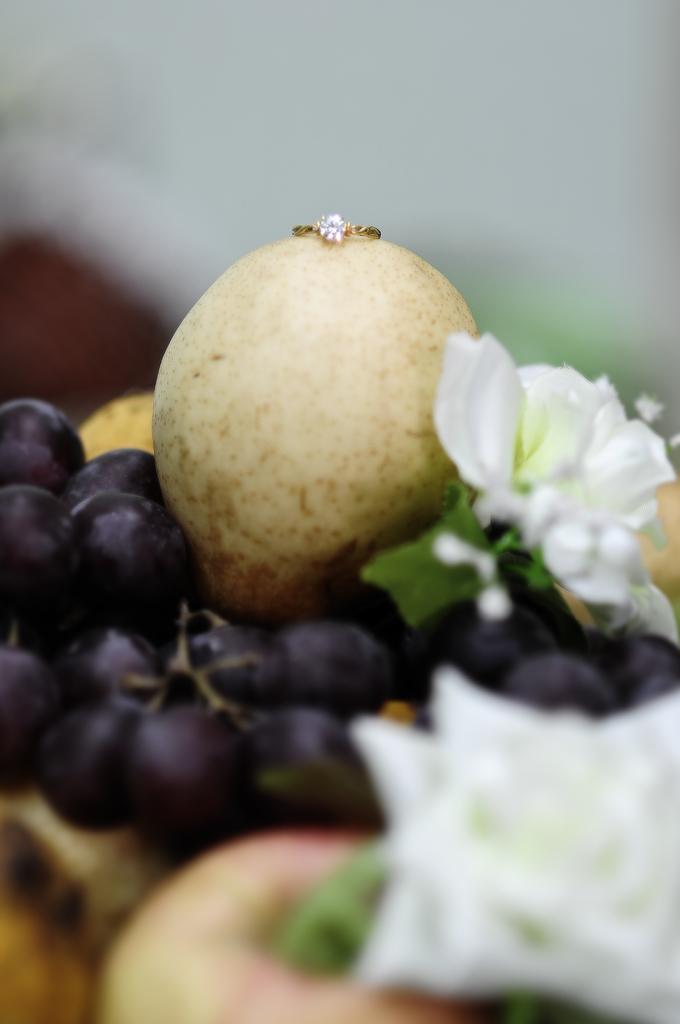Can you describe this image briefly? As we can see in the image there are black color grapes, white color flowers, ring and a wall. The background is blurred. 